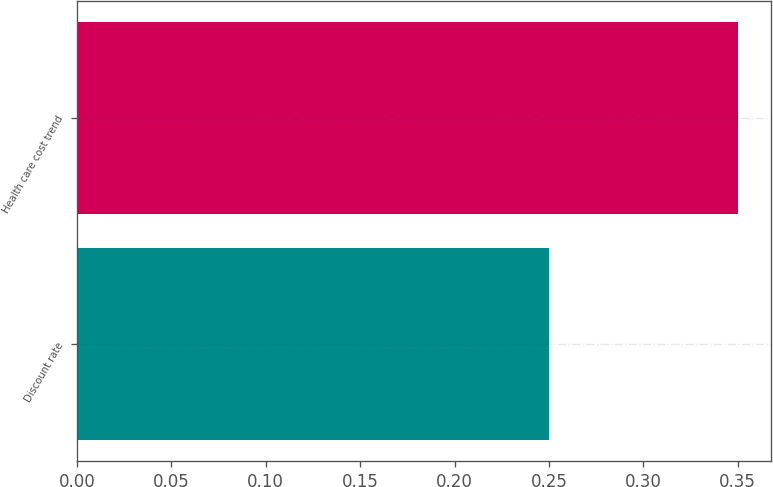Convert chart. <chart><loc_0><loc_0><loc_500><loc_500><bar_chart><fcel>Discount rate<fcel>Health care cost trend<nl><fcel>0.25<fcel>0.35<nl></chart> 